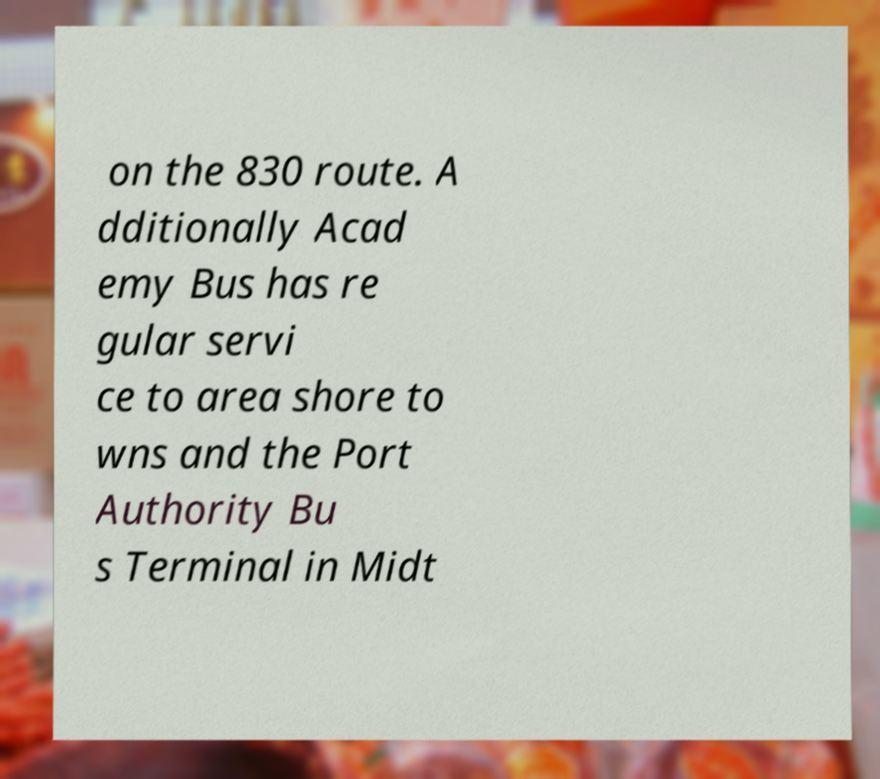I need the written content from this picture converted into text. Can you do that? on the 830 route. A dditionally Acad emy Bus has re gular servi ce to area shore to wns and the Port Authority Bu s Terminal in Midt 